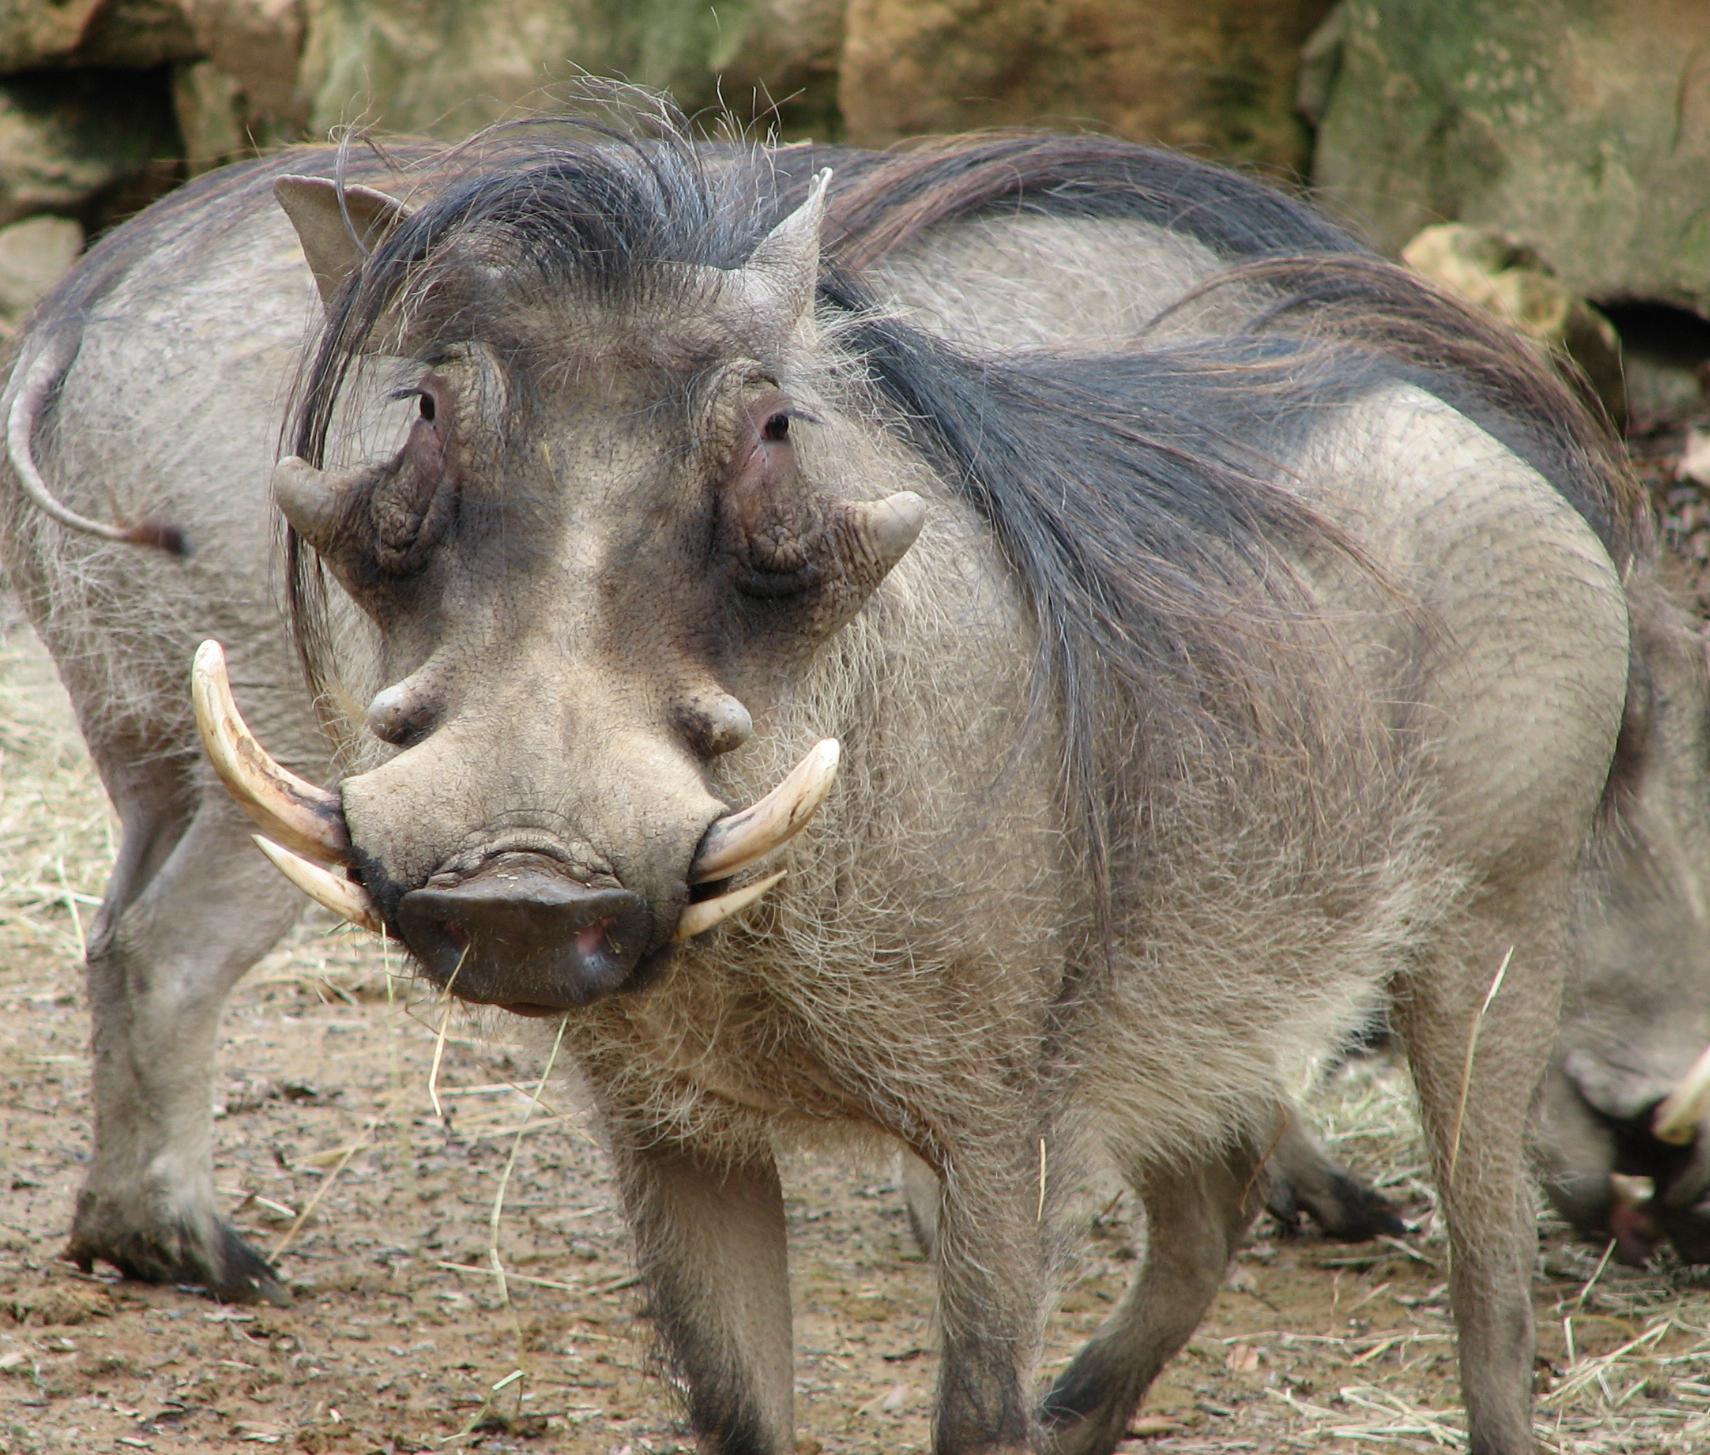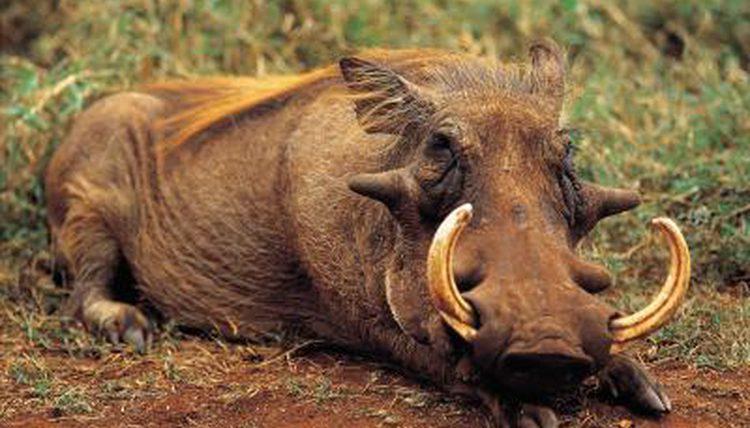The first image is the image on the left, the second image is the image on the right. Analyze the images presented: Is the assertion "There are at most four warthogs." valid? Answer yes or no. Yes. 